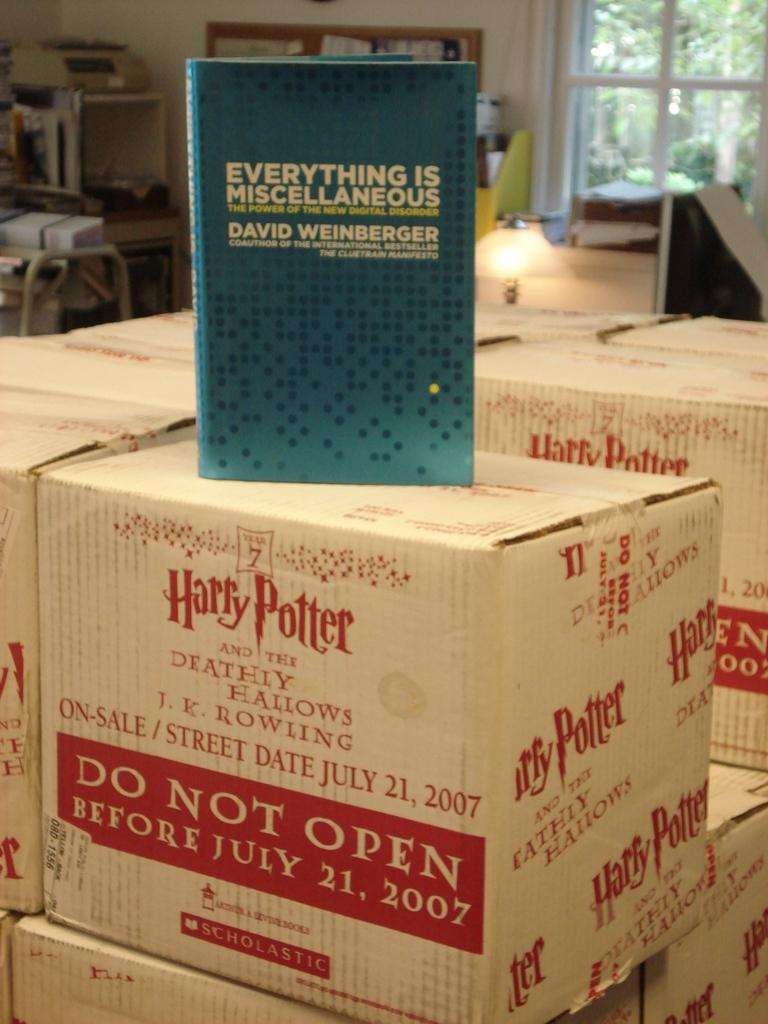<image>
Create a compact narrative representing the image presented. A blue book by David Weinberger is on top of a stack of boxes that say Harry Potter. 